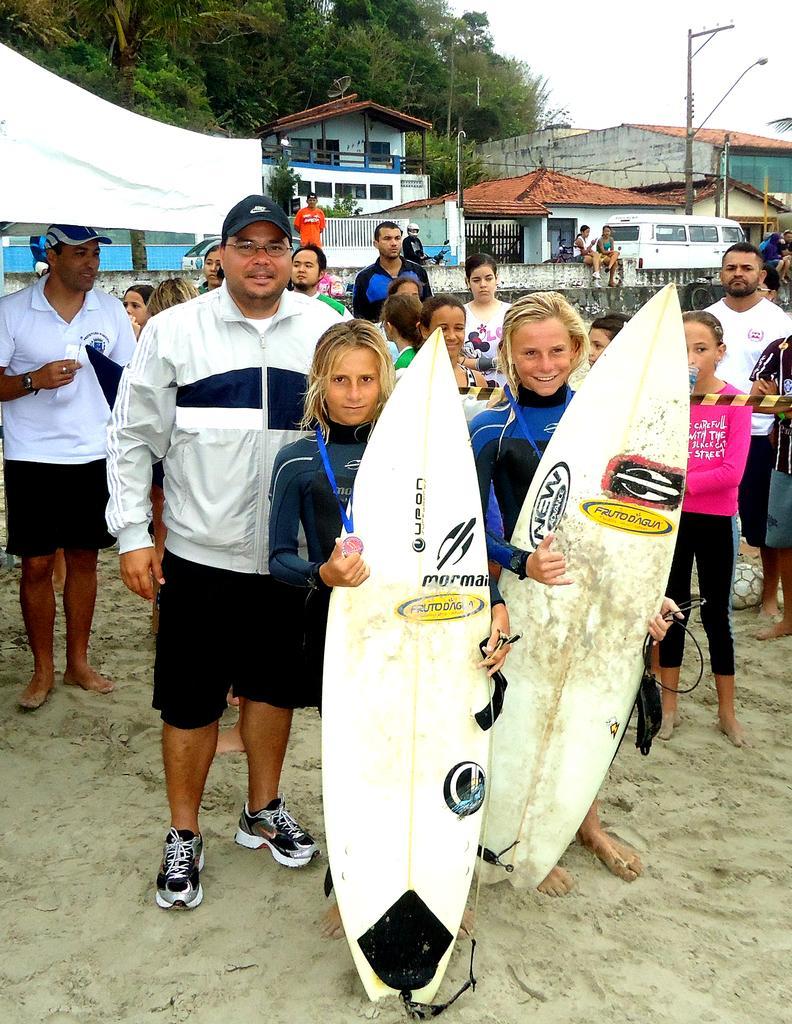Please provide a concise description of this image. In this image we can see two ladies holding surfing boards and we can also see houses, vehicle, trees and people. 